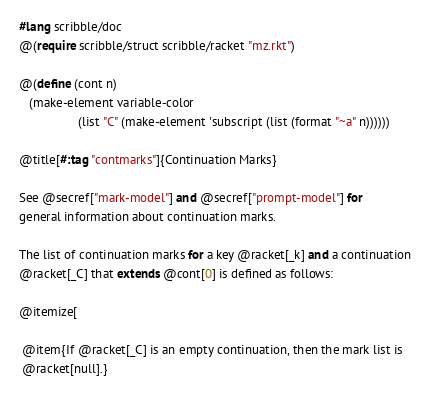Convert code to text. <code><loc_0><loc_0><loc_500><loc_500><_Racket_>#lang scribble/doc
@(require scribble/struct scribble/racket "mz.rkt")

@(define (cont n)
   (make-element variable-color
                 (list "C" (make-element 'subscript (list (format "~a" n))))))

@title[#:tag "contmarks"]{Continuation Marks}

See @secref["mark-model"] and @secref["prompt-model"] for
general information about continuation marks.

The list of continuation marks for a key @racket[_k] and a continuation
@racket[_C] that extends @cont[0] is defined as follows:

@itemize[

 @item{If @racket[_C] is an empty continuation, then the mark list is
 @racket[null].}
</code> 